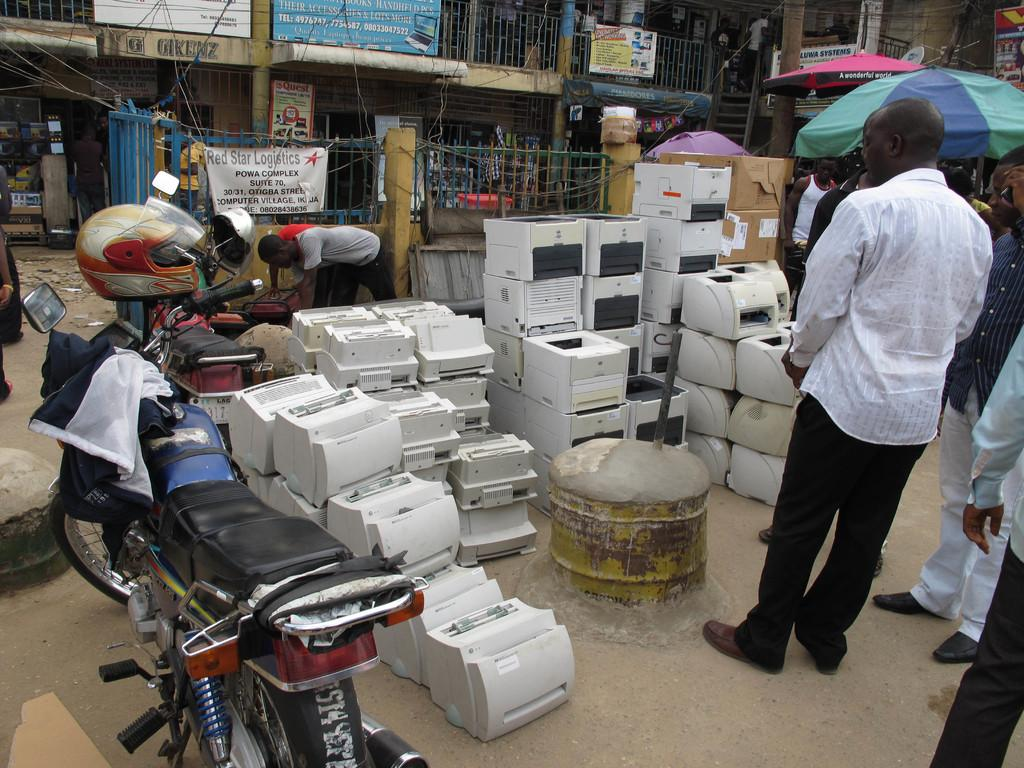What types of objects can be seen in the image? There are machines, people, an umbrella, vehicles, helmets, hoardings, and steps in the image. Can you describe the people in the image? There are people in the image, but their specific actions or roles cannot be determined from the provided facts. What might be used for protection from the elements in the image? The umbrella in the image might be used for protection from the elements. What types of vehicles are present in the image? The types of vehicles in the image cannot be determined from the provided facts. What might be used for advertising or displaying information in the image? The hoardings in the image might be used for advertising or displaying information. What architectural feature is present in the image? The steps in the image are an architectural feature. What type of feather can be seen on the helmets in the image? There are no feathers present on the helmets in the image. What type of curve can be seen in the machines in the image? The provided facts do not mention any curves in the machines in the image. 